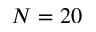Convert formula to latex. <formula><loc_0><loc_0><loc_500><loc_500>N = 2 0</formula> 